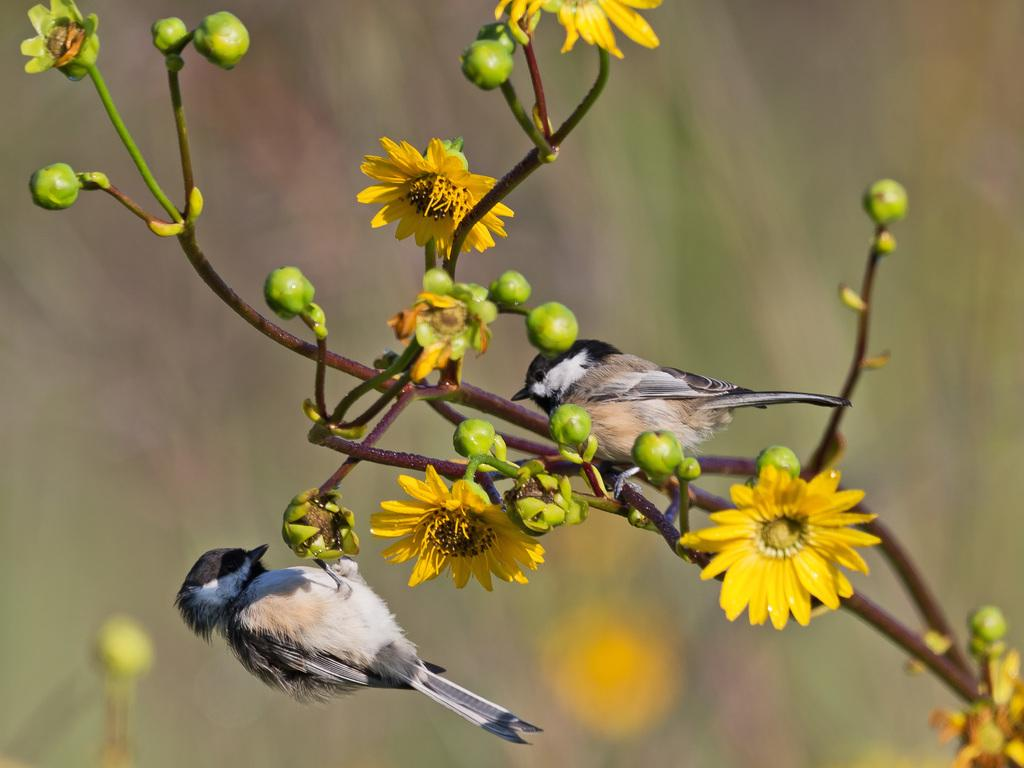What type of plant is in the image? There is a plant in the image with yellow flowers and green buds. What color are the flowers on the plant? The flowers on the plant are yellow. What else can be seen on the plant besides the flowers? The plant has green buds. Are there any animals present in the image? Yes, there are two birds sitting on the stem of the plant. What language do the birds on the plant speak? There is no indication in the image that the birds are speaking any language, and birds do not have the ability to speak human languages. 